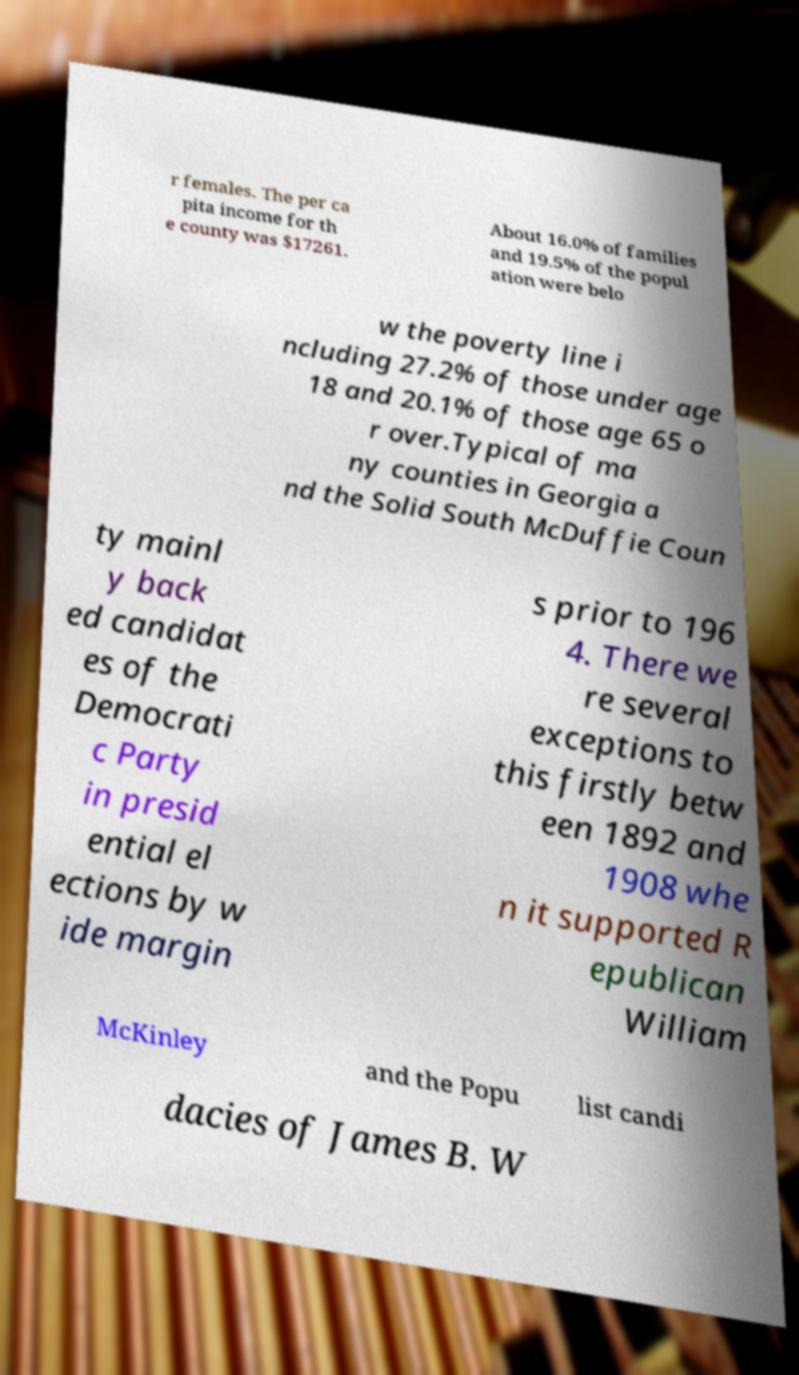For documentation purposes, I need the text within this image transcribed. Could you provide that? r females. The per ca pita income for th e county was $17261. About 16.0% of families and 19.5% of the popul ation were belo w the poverty line i ncluding 27.2% of those under age 18 and 20.1% of those age 65 o r over.Typical of ma ny counties in Georgia a nd the Solid South McDuffie Coun ty mainl y back ed candidat es of the Democrati c Party in presid ential el ections by w ide margin s prior to 196 4. There we re several exceptions to this firstly betw een 1892 and 1908 whe n it supported R epublican William McKinley and the Popu list candi dacies of James B. W 